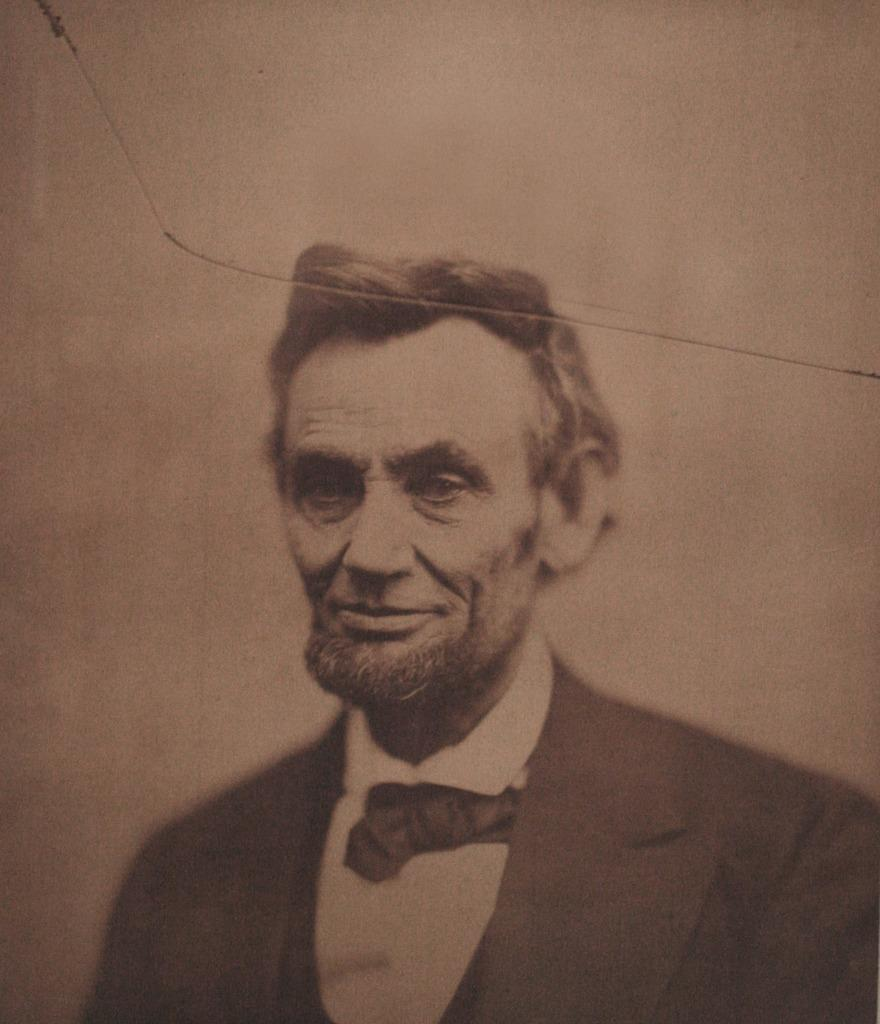What is the main subject of the image? The main subject of the image is a man. What type of clothing is the man wearing? The man is wearing a blazer and a bow tie. What is the man's facial expression in the image? The man is smiling in the image. What type of business is being conducted in the image? There is no indication of any business being conducted in the image; it simply shows a man wearing a blazer and bow tie while smiling. 